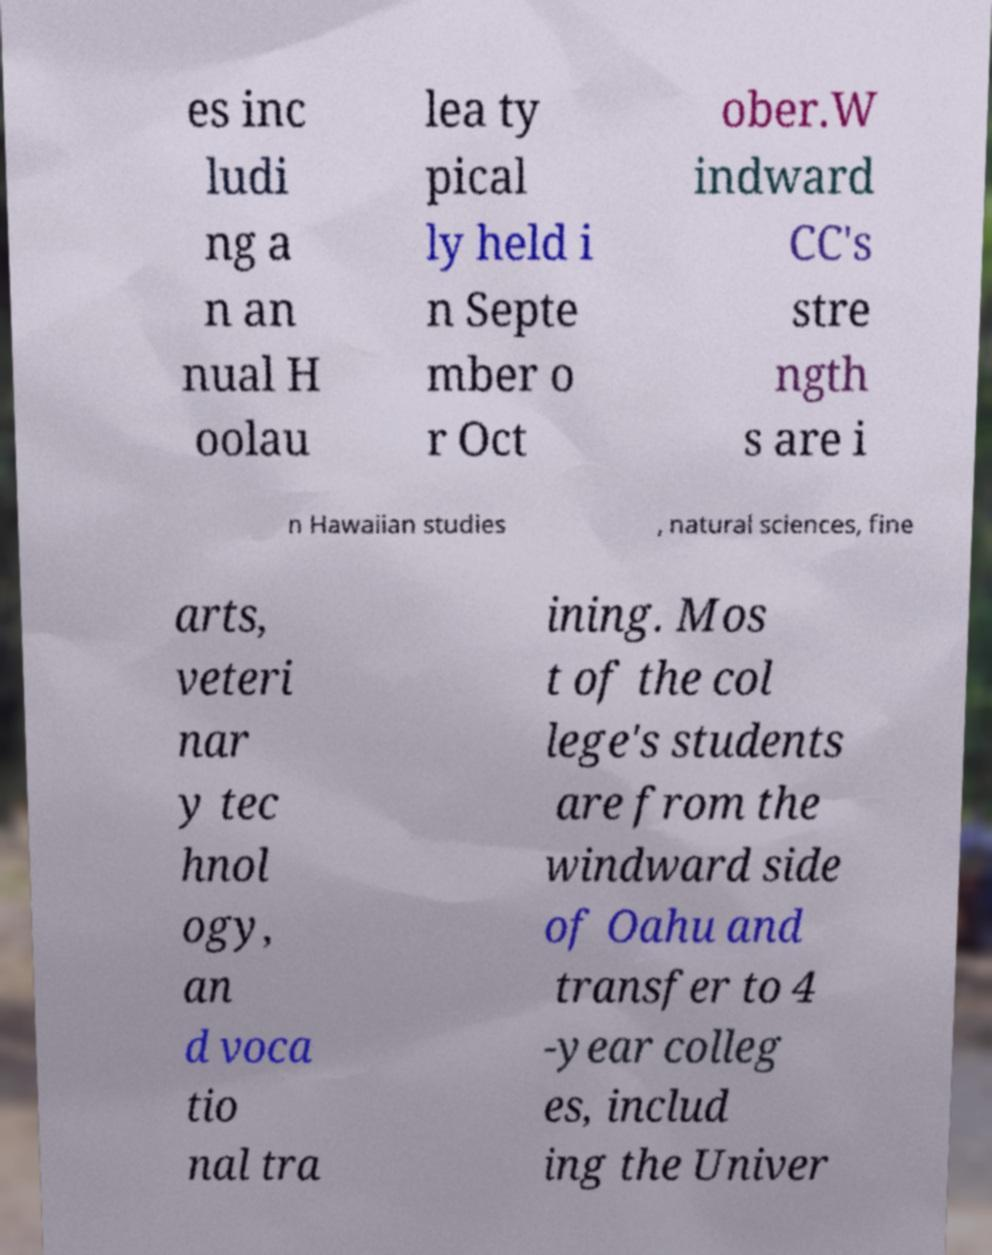What messages or text are displayed in this image? I need them in a readable, typed format. es inc ludi ng a n an nual H oolau lea ty pical ly held i n Septe mber o r Oct ober.W indward CC's stre ngth s are i n Hawaiian studies , natural sciences, fine arts, veteri nar y tec hnol ogy, an d voca tio nal tra ining. Mos t of the col lege's students are from the windward side of Oahu and transfer to 4 -year colleg es, includ ing the Univer 